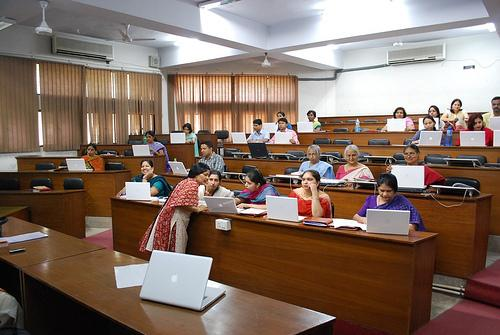Which country is this class most likely taught in? india 